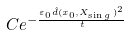<formula> <loc_0><loc_0><loc_500><loc_500>C e ^ { - \frac { \varepsilon _ { 0 } \hat { d } ( x _ { 0 } , X _ { \sin g \, } ) ^ { 2 } } { t } }</formula> 